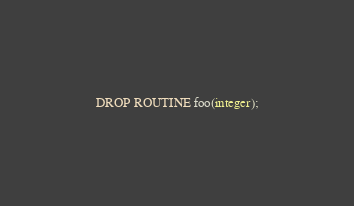<code> <loc_0><loc_0><loc_500><loc_500><_SQL_>DROP ROUTINE foo(integer);
</code> 